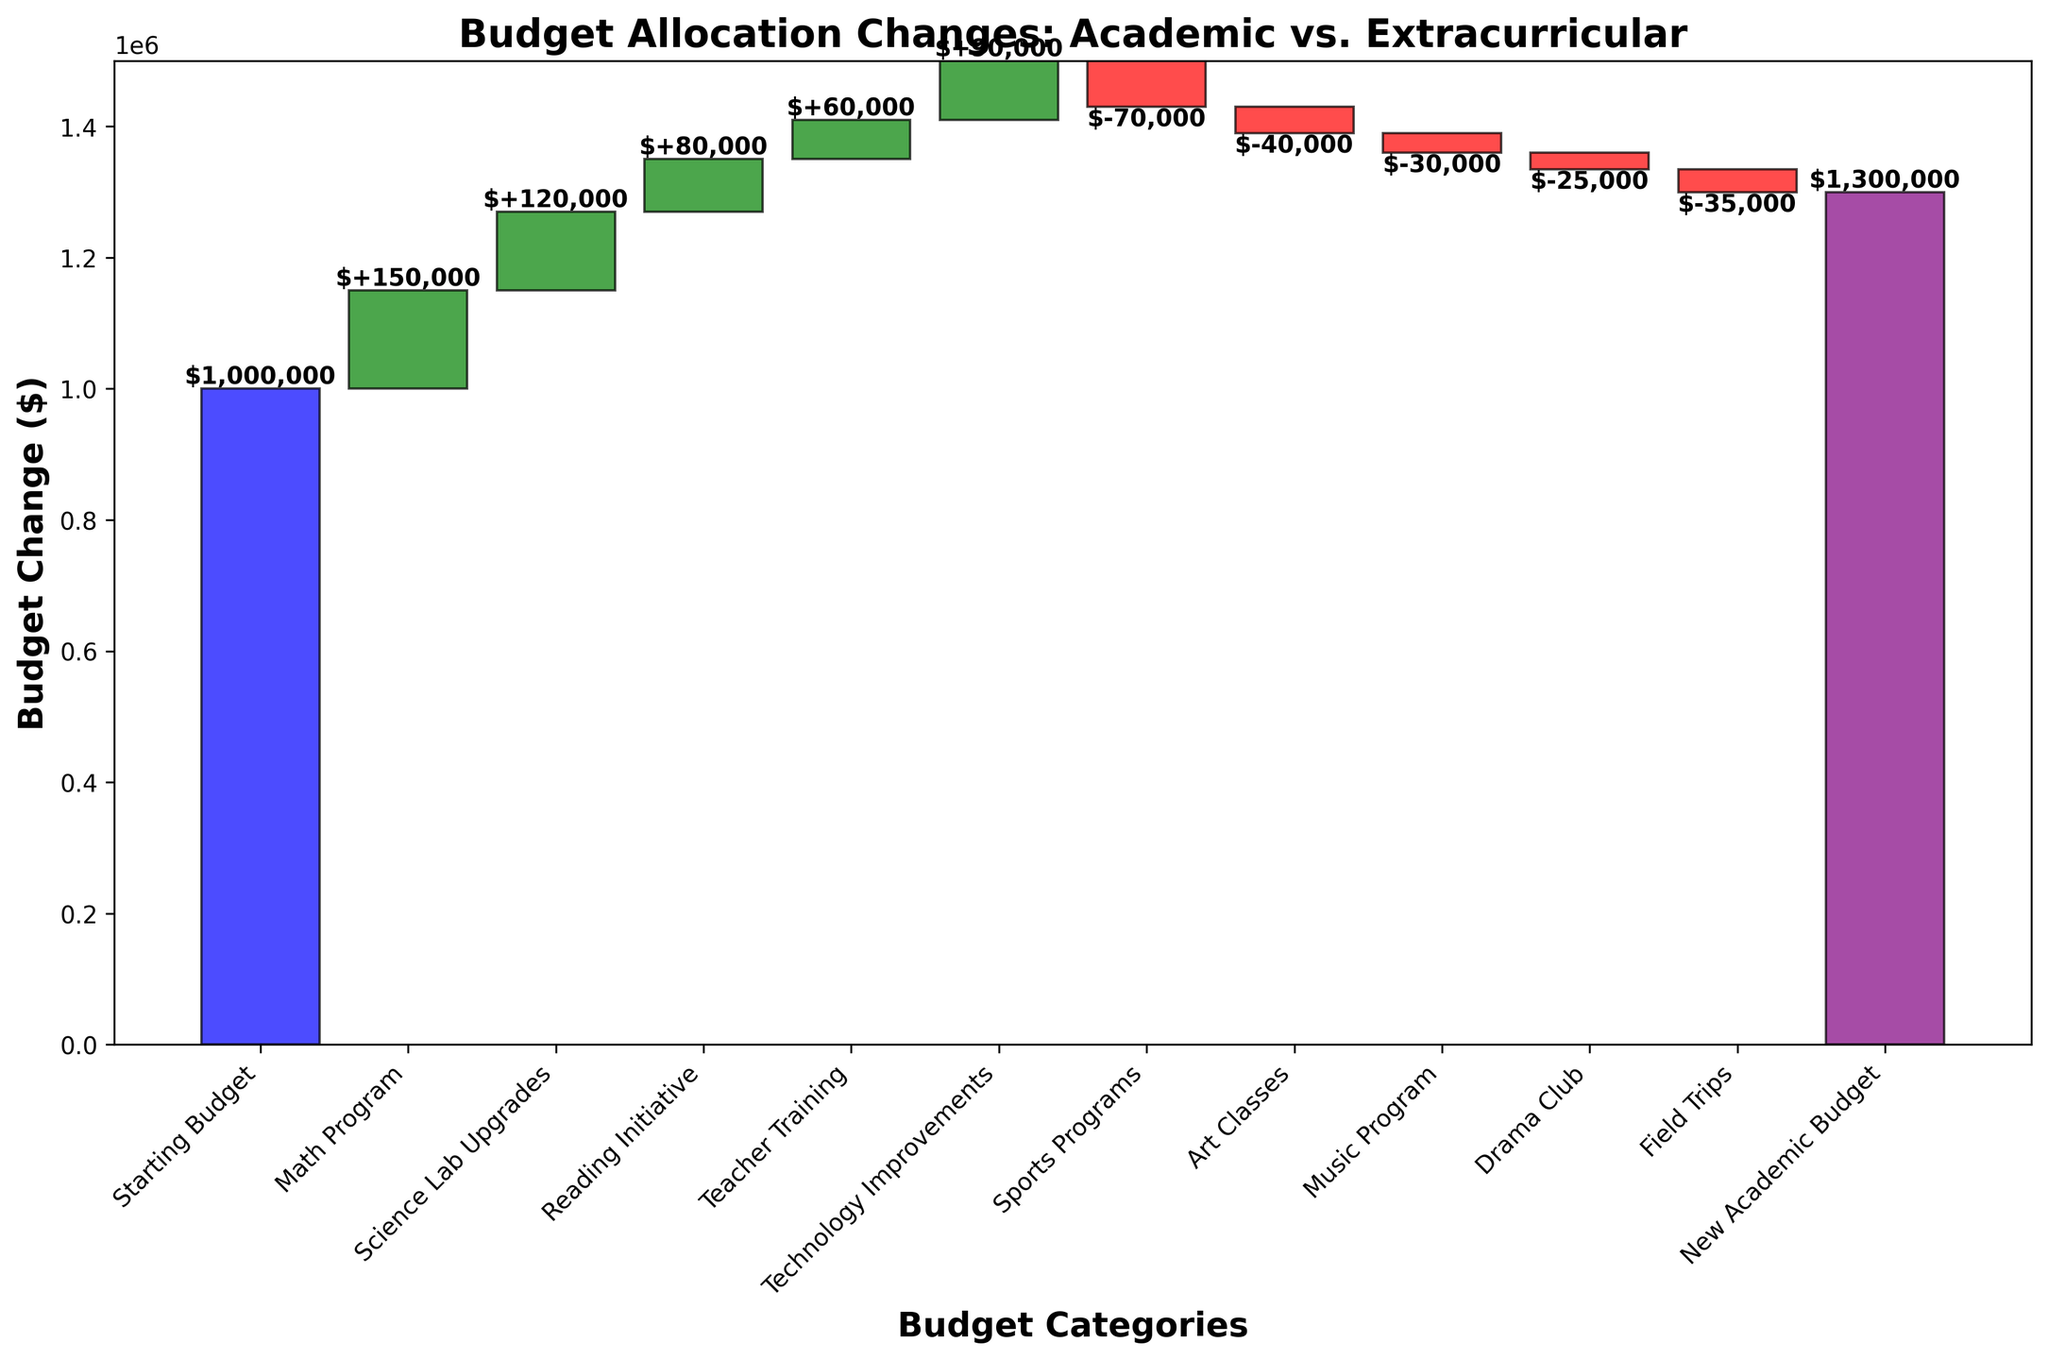What is the title of the figure? The title of the figure is located at the top of the chart and it summarizes the content of the chart. The title "Budget Allocation Changes: Academic vs. Extracurricular" indicates that the chart shows how the budget has been reallocated between academic programs and extracurricular activities.
Answer: Budget Allocation Changes: Academic vs. Extracurricular What is the new academic budget after the changes? The new academic budget is labeled at the end of the chart, with a purple bar representing the new total budget after all changes have been applied. The final value is provided at the end of this bar.
Answer: $1,300,000 How much budget was allocated to the Math Program? The Math Program is highlighted as one of the budget categories, marked with a green bar indicating positive change. The value, provided on or near the bar, shows the amount added.
Answer: $150,000 Which category received the largest decrease in budget? Looking at the bars that are red (indicating a decrease), we compare the lengths of these bars. The longest red bar represents the category with the largest budget decrease. The "Sports Programs" category has the longest red bar.
Answer: Sports Programs What is the total budget change from the initial budget to the new academic budget? To find the total budget change, we subtract the initial budget from the new academic budget. The initial budget is labeled at the start, and the new academic budget is at the end of the chart. ΔBudget = $1,300,000 - $1,000,000.
Answer: $300,000 How does the budget allocation for extracurricular activities compare to academic programs? Extracurricular activities are marked by negative changes (red bars), while academic programs are marked by positive changes (green bars). By visually comparing the number and size of green versus red bars, we can see that academic programs have received increases and extracurricular activities have seen reductions. There are more and larger increases (green bars) than decreases (red bars).
Answer: Academic programs received more budget allocation What is the cumulative budget after the Technology Improvements addition? The cumulative budget is calculated as the sum of the starting budget and the subsequent changes up to the point of interest. After Technology Improvements: $1,000,000 + $150,000 + $120,000 + $80,000 + $60,000 + $90,000.
Answer: $1,500,000 What portion of the reallocated budget was used for academic improvement? Summing the budget changes for academic-related categories - Math Program, Science Lab Upgrades, Reading Initiative, Teacher Training, and Technology Improvements. Total = $150,000 + $120,000 + $80,000 + $60,000 + $90,000.
Answer: $500,000 How many categories saw a positive change in their budget? Categories with a positive change are represented by green bars. By counting these green bars, you can easily determine the number of categories with a positive budget change.
Answer: 5 What is the net impact of changes in extracurricular activities on the budget? To find the net impact, sum the changes in all categories related to extracurricular activities (which are negative values). Net impact = -$70,000 - $40,000 - $30,000 - $25,000 - $35,000.
Answer: -$200,000 